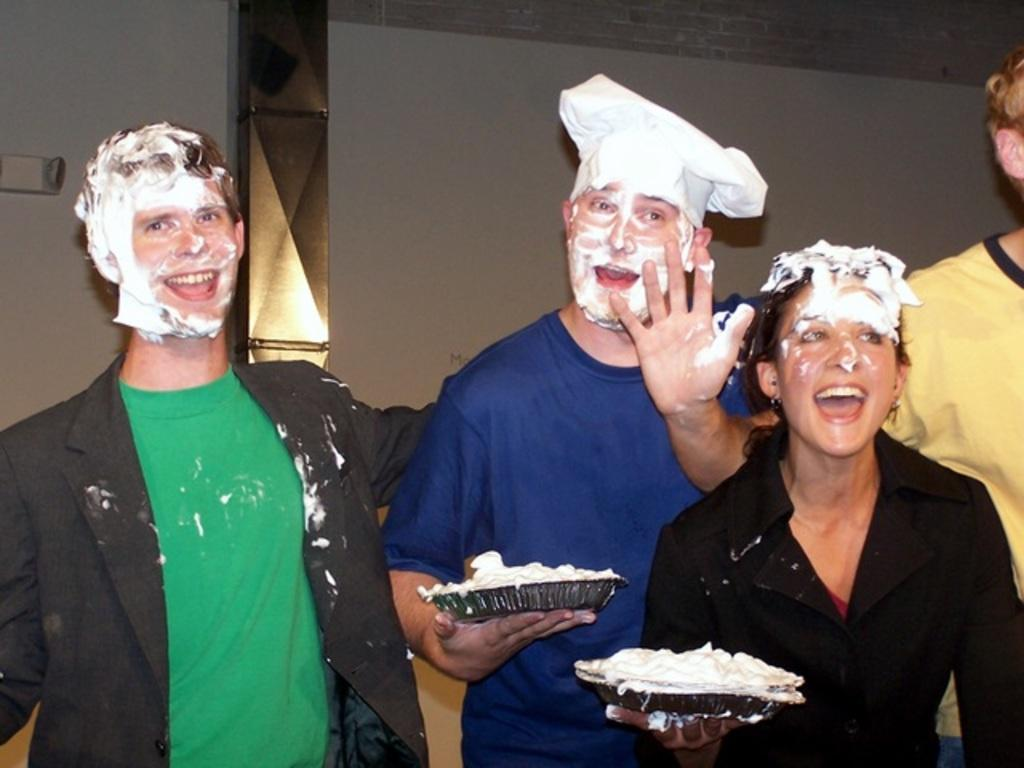How many people are present in the image? There are four persons in the image. What are two of the persons holding? Two of the persons are holding plates. Is there any indication of what might be on the plates? There might be cream on top of the plates. What can be seen in the background of the image? There is a wall in the background of the image. Can you tell me how many ants are crawling on the plates in the image? There are no ants present on the plates or in the image. Who is the expert in the image? There is no indication of an expert in the image. 